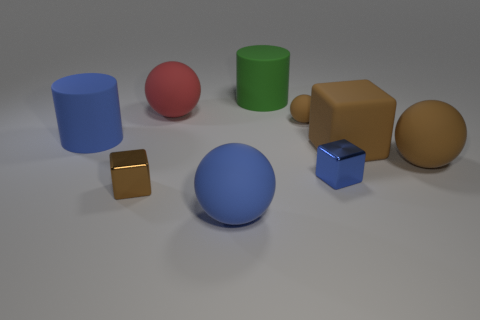Which of these objects appears the softest to the touch? The objects are rendered images and do not have actual textures, but the large brown capsule-shaped object has a matte finish and a soft-edge design that might suggest it would be soft to the touch.  If I needed to stack these objects, which one would provide the most stable base? The green cylinder would likely provide the most stable base for stacking due to its wide circular face and even surface. 